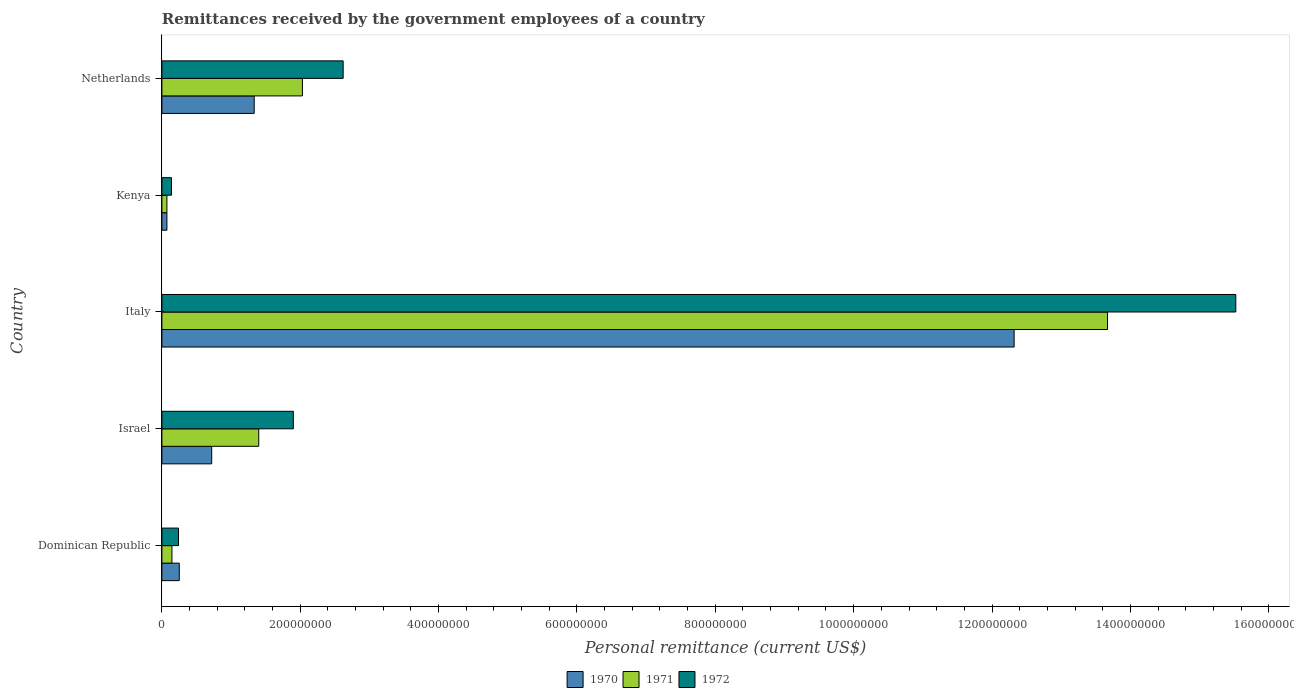How many different coloured bars are there?
Make the answer very short. 3. Are the number of bars per tick equal to the number of legend labels?
Provide a succinct answer. Yes. What is the label of the 2nd group of bars from the top?
Give a very brief answer. Kenya. In how many cases, is the number of bars for a given country not equal to the number of legend labels?
Your answer should be very brief. 0. What is the remittances received by the government employees in 1970 in Dominican Republic?
Keep it short and to the point. 2.51e+07. Across all countries, what is the maximum remittances received by the government employees in 1972?
Your response must be concise. 1.55e+09. Across all countries, what is the minimum remittances received by the government employees in 1971?
Make the answer very short. 7.26e+06. In which country was the remittances received by the government employees in 1971 maximum?
Give a very brief answer. Italy. In which country was the remittances received by the government employees in 1971 minimum?
Your answer should be compact. Kenya. What is the total remittances received by the government employees in 1971 in the graph?
Offer a very short reply. 1.73e+09. What is the difference between the remittances received by the government employees in 1971 in Israel and that in Netherlands?
Your response must be concise. -6.31e+07. What is the difference between the remittances received by the government employees in 1970 in Israel and the remittances received by the government employees in 1972 in Kenya?
Offer a very short reply. 5.81e+07. What is the average remittances received by the government employees in 1970 per country?
Keep it short and to the point. 2.94e+08. What is the difference between the remittances received by the government employees in 1972 and remittances received by the government employees in 1970 in Dominican Republic?
Offer a very short reply. -1.10e+06. What is the ratio of the remittances received by the government employees in 1970 in Dominican Republic to that in Kenya?
Make the answer very short. 3.46. Is the difference between the remittances received by the government employees in 1972 in Dominican Republic and Netherlands greater than the difference between the remittances received by the government employees in 1970 in Dominican Republic and Netherlands?
Give a very brief answer. No. What is the difference between the highest and the second highest remittances received by the government employees in 1972?
Provide a short and direct response. 1.29e+09. What is the difference between the highest and the lowest remittances received by the government employees in 1971?
Your answer should be very brief. 1.36e+09. In how many countries, is the remittances received by the government employees in 1971 greater than the average remittances received by the government employees in 1971 taken over all countries?
Give a very brief answer. 1. Is it the case that in every country, the sum of the remittances received by the government employees in 1971 and remittances received by the government employees in 1972 is greater than the remittances received by the government employees in 1970?
Provide a short and direct response. Yes. How many bars are there?
Offer a terse response. 15. Are all the bars in the graph horizontal?
Your answer should be compact. Yes. How many countries are there in the graph?
Provide a short and direct response. 5. Does the graph contain grids?
Offer a terse response. No. Where does the legend appear in the graph?
Make the answer very short. Bottom center. How many legend labels are there?
Offer a terse response. 3. What is the title of the graph?
Ensure brevity in your answer.  Remittances received by the government employees of a country. Does "2007" appear as one of the legend labels in the graph?
Provide a short and direct response. No. What is the label or title of the X-axis?
Provide a short and direct response. Personal remittance (current US$). What is the Personal remittance (current US$) in 1970 in Dominican Republic?
Your response must be concise. 2.51e+07. What is the Personal remittance (current US$) in 1971 in Dominican Republic?
Give a very brief answer. 1.45e+07. What is the Personal remittance (current US$) of 1972 in Dominican Republic?
Provide a short and direct response. 2.40e+07. What is the Personal remittance (current US$) in 1970 in Israel?
Give a very brief answer. 7.20e+07. What is the Personal remittance (current US$) in 1971 in Israel?
Ensure brevity in your answer.  1.40e+08. What is the Personal remittance (current US$) in 1972 in Israel?
Your answer should be compact. 1.90e+08. What is the Personal remittance (current US$) in 1970 in Italy?
Offer a terse response. 1.23e+09. What is the Personal remittance (current US$) in 1971 in Italy?
Provide a succinct answer. 1.37e+09. What is the Personal remittance (current US$) in 1972 in Italy?
Your answer should be very brief. 1.55e+09. What is the Personal remittance (current US$) in 1970 in Kenya?
Your answer should be compact. 7.26e+06. What is the Personal remittance (current US$) in 1971 in Kenya?
Offer a very short reply. 7.26e+06. What is the Personal remittance (current US$) of 1972 in Kenya?
Your answer should be compact. 1.39e+07. What is the Personal remittance (current US$) of 1970 in Netherlands?
Offer a very short reply. 1.33e+08. What is the Personal remittance (current US$) in 1971 in Netherlands?
Give a very brief answer. 2.03e+08. What is the Personal remittance (current US$) in 1972 in Netherlands?
Give a very brief answer. 2.62e+08. Across all countries, what is the maximum Personal remittance (current US$) of 1970?
Keep it short and to the point. 1.23e+09. Across all countries, what is the maximum Personal remittance (current US$) of 1971?
Provide a succinct answer. 1.37e+09. Across all countries, what is the maximum Personal remittance (current US$) of 1972?
Offer a terse response. 1.55e+09. Across all countries, what is the minimum Personal remittance (current US$) of 1970?
Ensure brevity in your answer.  7.26e+06. Across all countries, what is the minimum Personal remittance (current US$) in 1971?
Your response must be concise. 7.26e+06. Across all countries, what is the minimum Personal remittance (current US$) of 1972?
Keep it short and to the point. 1.39e+07. What is the total Personal remittance (current US$) in 1970 in the graph?
Make the answer very short. 1.47e+09. What is the total Personal remittance (current US$) of 1971 in the graph?
Ensure brevity in your answer.  1.73e+09. What is the total Personal remittance (current US$) in 1972 in the graph?
Your response must be concise. 2.04e+09. What is the difference between the Personal remittance (current US$) in 1970 in Dominican Republic and that in Israel?
Offer a very short reply. -4.69e+07. What is the difference between the Personal remittance (current US$) of 1971 in Dominican Republic and that in Israel?
Your answer should be very brief. -1.26e+08. What is the difference between the Personal remittance (current US$) in 1972 in Dominican Republic and that in Israel?
Your answer should be very brief. -1.66e+08. What is the difference between the Personal remittance (current US$) in 1970 in Dominican Republic and that in Italy?
Keep it short and to the point. -1.21e+09. What is the difference between the Personal remittance (current US$) in 1971 in Dominican Republic and that in Italy?
Make the answer very short. -1.35e+09. What is the difference between the Personal remittance (current US$) of 1972 in Dominican Republic and that in Italy?
Your answer should be very brief. -1.53e+09. What is the difference between the Personal remittance (current US$) of 1970 in Dominican Republic and that in Kenya?
Your answer should be very brief. 1.78e+07. What is the difference between the Personal remittance (current US$) in 1971 in Dominican Republic and that in Kenya?
Provide a short and direct response. 7.24e+06. What is the difference between the Personal remittance (current US$) of 1972 in Dominican Republic and that in Kenya?
Make the answer very short. 1.01e+07. What is the difference between the Personal remittance (current US$) of 1970 in Dominican Republic and that in Netherlands?
Ensure brevity in your answer.  -1.08e+08. What is the difference between the Personal remittance (current US$) in 1971 in Dominican Republic and that in Netherlands?
Offer a terse response. -1.89e+08. What is the difference between the Personal remittance (current US$) in 1972 in Dominican Republic and that in Netherlands?
Offer a very short reply. -2.38e+08. What is the difference between the Personal remittance (current US$) in 1970 in Israel and that in Italy?
Your response must be concise. -1.16e+09. What is the difference between the Personal remittance (current US$) of 1971 in Israel and that in Italy?
Ensure brevity in your answer.  -1.23e+09. What is the difference between the Personal remittance (current US$) in 1972 in Israel and that in Italy?
Give a very brief answer. -1.36e+09. What is the difference between the Personal remittance (current US$) of 1970 in Israel and that in Kenya?
Ensure brevity in your answer.  6.47e+07. What is the difference between the Personal remittance (current US$) of 1971 in Israel and that in Kenya?
Provide a succinct answer. 1.33e+08. What is the difference between the Personal remittance (current US$) in 1972 in Israel and that in Kenya?
Provide a short and direct response. 1.76e+08. What is the difference between the Personal remittance (current US$) of 1970 in Israel and that in Netherlands?
Offer a terse response. -6.14e+07. What is the difference between the Personal remittance (current US$) of 1971 in Israel and that in Netherlands?
Keep it short and to the point. -6.31e+07. What is the difference between the Personal remittance (current US$) in 1972 in Israel and that in Netherlands?
Ensure brevity in your answer.  -7.20e+07. What is the difference between the Personal remittance (current US$) in 1970 in Italy and that in Kenya?
Your answer should be very brief. 1.22e+09. What is the difference between the Personal remittance (current US$) of 1971 in Italy and that in Kenya?
Offer a very short reply. 1.36e+09. What is the difference between the Personal remittance (current US$) in 1972 in Italy and that in Kenya?
Give a very brief answer. 1.54e+09. What is the difference between the Personal remittance (current US$) of 1970 in Italy and that in Netherlands?
Make the answer very short. 1.10e+09. What is the difference between the Personal remittance (current US$) in 1971 in Italy and that in Netherlands?
Provide a short and direct response. 1.16e+09. What is the difference between the Personal remittance (current US$) of 1972 in Italy and that in Netherlands?
Provide a short and direct response. 1.29e+09. What is the difference between the Personal remittance (current US$) in 1970 in Kenya and that in Netherlands?
Make the answer very short. -1.26e+08. What is the difference between the Personal remittance (current US$) in 1971 in Kenya and that in Netherlands?
Your answer should be very brief. -1.96e+08. What is the difference between the Personal remittance (current US$) in 1972 in Kenya and that in Netherlands?
Your response must be concise. -2.48e+08. What is the difference between the Personal remittance (current US$) of 1970 in Dominican Republic and the Personal remittance (current US$) of 1971 in Israel?
Offer a very short reply. -1.15e+08. What is the difference between the Personal remittance (current US$) in 1970 in Dominican Republic and the Personal remittance (current US$) in 1972 in Israel?
Make the answer very short. -1.65e+08. What is the difference between the Personal remittance (current US$) of 1971 in Dominican Republic and the Personal remittance (current US$) of 1972 in Israel?
Offer a very short reply. -1.76e+08. What is the difference between the Personal remittance (current US$) of 1970 in Dominican Republic and the Personal remittance (current US$) of 1971 in Italy?
Your answer should be very brief. -1.34e+09. What is the difference between the Personal remittance (current US$) in 1970 in Dominican Republic and the Personal remittance (current US$) in 1972 in Italy?
Make the answer very short. -1.53e+09. What is the difference between the Personal remittance (current US$) in 1971 in Dominican Republic and the Personal remittance (current US$) in 1972 in Italy?
Your answer should be very brief. -1.54e+09. What is the difference between the Personal remittance (current US$) of 1970 in Dominican Republic and the Personal remittance (current US$) of 1971 in Kenya?
Ensure brevity in your answer.  1.78e+07. What is the difference between the Personal remittance (current US$) in 1970 in Dominican Republic and the Personal remittance (current US$) in 1972 in Kenya?
Keep it short and to the point. 1.12e+07. What is the difference between the Personal remittance (current US$) in 1971 in Dominican Republic and the Personal remittance (current US$) in 1972 in Kenya?
Your answer should be compact. 6.40e+05. What is the difference between the Personal remittance (current US$) of 1970 in Dominican Republic and the Personal remittance (current US$) of 1971 in Netherlands?
Make the answer very short. -1.78e+08. What is the difference between the Personal remittance (current US$) in 1970 in Dominican Republic and the Personal remittance (current US$) in 1972 in Netherlands?
Make the answer very short. -2.37e+08. What is the difference between the Personal remittance (current US$) of 1971 in Dominican Republic and the Personal remittance (current US$) of 1972 in Netherlands?
Make the answer very short. -2.48e+08. What is the difference between the Personal remittance (current US$) of 1970 in Israel and the Personal remittance (current US$) of 1971 in Italy?
Offer a very short reply. -1.30e+09. What is the difference between the Personal remittance (current US$) in 1970 in Israel and the Personal remittance (current US$) in 1972 in Italy?
Your answer should be compact. -1.48e+09. What is the difference between the Personal remittance (current US$) of 1971 in Israel and the Personal remittance (current US$) of 1972 in Italy?
Keep it short and to the point. -1.41e+09. What is the difference between the Personal remittance (current US$) of 1970 in Israel and the Personal remittance (current US$) of 1971 in Kenya?
Offer a very short reply. 6.47e+07. What is the difference between the Personal remittance (current US$) in 1970 in Israel and the Personal remittance (current US$) in 1972 in Kenya?
Keep it short and to the point. 5.81e+07. What is the difference between the Personal remittance (current US$) of 1971 in Israel and the Personal remittance (current US$) of 1972 in Kenya?
Keep it short and to the point. 1.26e+08. What is the difference between the Personal remittance (current US$) in 1970 in Israel and the Personal remittance (current US$) in 1971 in Netherlands?
Give a very brief answer. -1.31e+08. What is the difference between the Personal remittance (current US$) of 1970 in Israel and the Personal remittance (current US$) of 1972 in Netherlands?
Your answer should be very brief. -1.90e+08. What is the difference between the Personal remittance (current US$) in 1971 in Israel and the Personal remittance (current US$) in 1972 in Netherlands?
Provide a short and direct response. -1.22e+08. What is the difference between the Personal remittance (current US$) of 1970 in Italy and the Personal remittance (current US$) of 1971 in Kenya?
Keep it short and to the point. 1.22e+09. What is the difference between the Personal remittance (current US$) in 1970 in Italy and the Personal remittance (current US$) in 1972 in Kenya?
Ensure brevity in your answer.  1.22e+09. What is the difference between the Personal remittance (current US$) in 1971 in Italy and the Personal remittance (current US$) in 1972 in Kenya?
Ensure brevity in your answer.  1.35e+09. What is the difference between the Personal remittance (current US$) of 1970 in Italy and the Personal remittance (current US$) of 1971 in Netherlands?
Give a very brief answer. 1.03e+09. What is the difference between the Personal remittance (current US$) in 1970 in Italy and the Personal remittance (current US$) in 1972 in Netherlands?
Make the answer very short. 9.70e+08. What is the difference between the Personal remittance (current US$) in 1971 in Italy and the Personal remittance (current US$) in 1972 in Netherlands?
Your answer should be compact. 1.10e+09. What is the difference between the Personal remittance (current US$) of 1970 in Kenya and the Personal remittance (current US$) of 1971 in Netherlands?
Keep it short and to the point. -1.96e+08. What is the difference between the Personal remittance (current US$) in 1970 in Kenya and the Personal remittance (current US$) in 1972 in Netherlands?
Ensure brevity in your answer.  -2.55e+08. What is the difference between the Personal remittance (current US$) in 1971 in Kenya and the Personal remittance (current US$) in 1972 in Netherlands?
Your answer should be very brief. -2.55e+08. What is the average Personal remittance (current US$) in 1970 per country?
Your answer should be compact. 2.94e+08. What is the average Personal remittance (current US$) of 1971 per country?
Provide a succinct answer. 3.46e+08. What is the average Personal remittance (current US$) of 1972 per country?
Your response must be concise. 4.08e+08. What is the difference between the Personal remittance (current US$) in 1970 and Personal remittance (current US$) in 1971 in Dominican Republic?
Ensure brevity in your answer.  1.06e+07. What is the difference between the Personal remittance (current US$) in 1970 and Personal remittance (current US$) in 1972 in Dominican Republic?
Your response must be concise. 1.10e+06. What is the difference between the Personal remittance (current US$) of 1971 and Personal remittance (current US$) of 1972 in Dominican Republic?
Provide a short and direct response. -9.50e+06. What is the difference between the Personal remittance (current US$) in 1970 and Personal remittance (current US$) in 1971 in Israel?
Offer a very short reply. -6.80e+07. What is the difference between the Personal remittance (current US$) in 1970 and Personal remittance (current US$) in 1972 in Israel?
Keep it short and to the point. -1.18e+08. What is the difference between the Personal remittance (current US$) in 1971 and Personal remittance (current US$) in 1972 in Israel?
Ensure brevity in your answer.  -5.00e+07. What is the difference between the Personal remittance (current US$) of 1970 and Personal remittance (current US$) of 1971 in Italy?
Keep it short and to the point. -1.35e+08. What is the difference between the Personal remittance (current US$) of 1970 and Personal remittance (current US$) of 1972 in Italy?
Keep it short and to the point. -3.20e+08. What is the difference between the Personal remittance (current US$) of 1971 and Personal remittance (current US$) of 1972 in Italy?
Make the answer very short. -1.85e+08. What is the difference between the Personal remittance (current US$) in 1970 and Personal remittance (current US$) in 1972 in Kenya?
Give a very brief answer. -6.60e+06. What is the difference between the Personal remittance (current US$) in 1971 and Personal remittance (current US$) in 1972 in Kenya?
Make the answer very short. -6.60e+06. What is the difference between the Personal remittance (current US$) of 1970 and Personal remittance (current US$) of 1971 in Netherlands?
Give a very brief answer. -6.97e+07. What is the difference between the Personal remittance (current US$) in 1970 and Personal remittance (current US$) in 1972 in Netherlands?
Give a very brief answer. -1.29e+08. What is the difference between the Personal remittance (current US$) in 1971 and Personal remittance (current US$) in 1972 in Netherlands?
Ensure brevity in your answer.  -5.89e+07. What is the ratio of the Personal remittance (current US$) of 1970 in Dominican Republic to that in Israel?
Make the answer very short. 0.35. What is the ratio of the Personal remittance (current US$) of 1971 in Dominican Republic to that in Israel?
Your answer should be compact. 0.1. What is the ratio of the Personal remittance (current US$) in 1972 in Dominican Republic to that in Israel?
Your answer should be compact. 0.13. What is the ratio of the Personal remittance (current US$) in 1970 in Dominican Republic to that in Italy?
Give a very brief answer. 0.02. What is the ratio of the Personal remittance (current US$) in 1971 in Dominican Republic to that in Italy?
Your answer should be very brief. 0.01. What is the ratio of the Personal remittance (current US$) in 1972 in Dominican Republic to that in Italy?
Offer a terse response. 0.02. What is the ratio of the Personal remittance (current US$) in 1970 in Dominican Republic to that in Kenya?
Give a very brief answer. 3.46. What is the ratio of the Personal remittance (current US$) in 1971 in Dominican Republic to that in Kenya?
Offer a very short reply. 2. What is the ratio of the Personal remittance (current US$) in 1972 in Dominican Republic to that in Kenya?
Provide a short and direct response. 1.73. What is the ratio of the Personal remittance (current US$) in 1970 in Dominican Republic to that in Netherlands?
Make the answer very short. 0.19. What is the ratio of the Personal remittance (current US$) of 1971 in Dominican Republic to that in Netherlands?
Your response must be concise. 0.07. What is the ratio of the Personal remittance (current US$) of 1972 in Dominican Republic to that in Netherlands?
Give a very brief answer. 0.09. What is the ratio of the Personal remittance (current US$) in 1970 in Israel to that in Italy?
Make the answer very short. 0.06. What is the ratio of the Personal remittance (current US$) of 1971 in Israel to that in Italy?
Provide a succinct answer. 0.1. What is the ratio of the Personal remittance (current US$) of 1972 in Israel to that in Italy?
Make the answer very short. 0.12. What is the ratio of the Personal remittance (current US$) of 1970 in Israel to that in Kenya?
Keep it short and to the point. 9.92. What is the ratio of the Personal remittance (current US$) in 1971 in Israel to that in Kenya?
Your response must be concise. 19.28. What is the ratio of the Personal remittance (current US$) in 1972 in Israel to that in Kenya?
Provide a succinct answer. 13.71. What is the ratio of the Personal remittance (current US$) of 1970 in Israel to that in Netherlands?
Give a very brief answer. 0.54. What is the ratio of the Personal remittance (current US$) in 1971 in Israel to that in Netherlands?
Make the answer very short. 0.69. What is the ratio of the Personal remittance (current US$) of 1972 in Israel to that in Netherlands?
Keep it short and to the point. 0.73. What is the ratio of the Personal remittance (current US$) of 1970 in Italy to that in Kenya?
Offer a terse response. 169.7. What is the ratio of the Personal remittance (current US$) in 1971 in Italy to that in Kenya?
Provide a succinct answer. 188.29. What is the ratio of the Personal remittance (current US$) in 1972 in Italy to that in Kenya?
Provide a short and direct response. 112.01. What is the ratio of the Personal remittance (current US$) in 1970 in Italy to that in Netherlands?
Your response must be concise. 9.23. What is the ratio of the Personal remittance (current US$) in 1971 in Italy to that in Netherlands?
Your response must be concise. 6.73. What is the ratio of the Personal remittance (current US$) in 1972 in Italy to that in Netherlands?
Give a very brief answer. 5.92. What is the ratio of the Personal remittance (current US$) in 1970 in Kenya to that in Netherlands?
Your answer should be compact. 0.05. What is the ratio of the Personal remittance (current US$) of 1971 in Kenya to that in Netherlands?
Provide a short and direct response. 0.04. What is the ratio of the Personal remittance (current US$) in 1972 in Kenya to that in Netherlands?
Give a very brief answer. 0.05. What is the difference between the highest and the second highest Personal remittance (current US$) in 1970?
Ensure brevity in your answer.  1.10e+09. What is the difference between the highest and the second highest Personal remittance (current US$) of 1971?
Offer a terse response. 1.16e+09. What is the difference between the highest and the second highest Personal remittance (current US$) of 1972?
Your response must be concise. 1.29e+09. What is the difference between the highest and the lowest Personal remittance (current US$) of 1970?
Your answer should be very brief. 1.22e+09. What is the difference between the highest and the lowest Personal remittance (current US$) of 1971?
Give a very brief answer. 1.36e+09. What is the difference between the highest and the lowest Personal remittance (current US$) in 1972?
Give a very brief answer. 1.54e+09. 